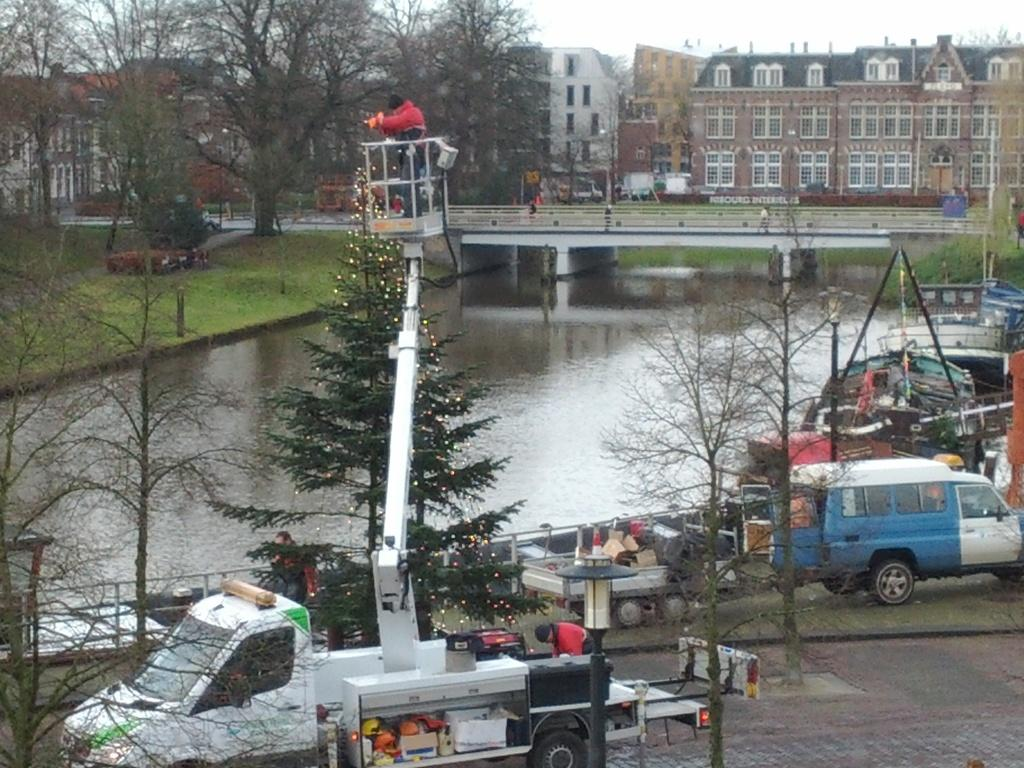What types of vehicles can be seen in the image? There are vehicles in the image, but the specific types are not mentioned. What is located in the foreground of the image? There are objects in the foreground of the image, but their nature is not specified. What type of natural environment is visible in the image? There are trees and a water surface visible in the image, suggesting a natural setting. What type of structure can be seen in the image? There is a bridge in the image, which is a man-made structure. What type of buildings are present in the image? There are buildings in the image, but their specific types are not mentioned. What type of leather is used to make the farmer's hat in the image? There is no farmer or hat present in the image, so it is not possible to answer that question. Where is the bedroom located in the image? There is no bedroom present in the image. 